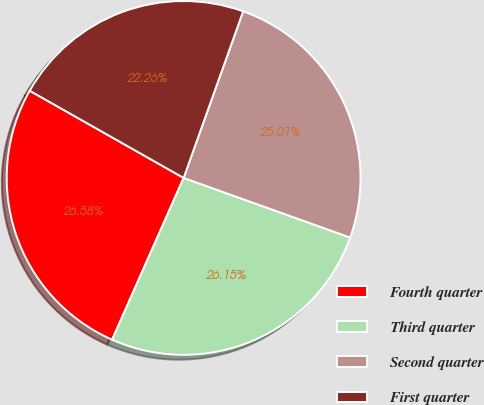<chart> <loc_0><loc_0><loc_500><loc_500><pie_chart><fcel>Fourth quarter<fcel>Third quarter<fcel>Second quarter<fcel>First quarter<nl><fcel>26.58%<fcel>26.15%<fcel>25.01%<fcel>22.26%<nl></chart> 